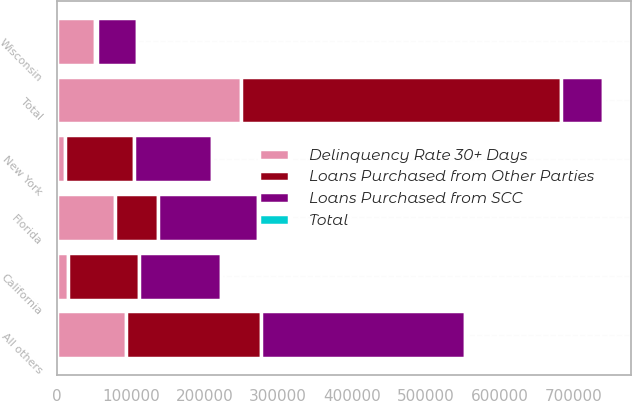Convert chart. <chart><loc_0><loc_0><loc_500><loc_500><stacked_bar_chart><ecel><fcel>Florida<fcel>California<fcel>New York<fcel>Wisconsin<fcel>All others<fcel>Total<nl><fcel>Loans Purchased from Other Parties<fcel>57396<fcel>96830<fcel>94626<fcel>2214<fcel>183578<fcel>434644<nl><fcel>Delinquency Rate 30+ Days<fcel>78999<fcel>14546<fcel>10305<fcel>51947<fcel>93243<fcel>249040<nl><fcel>Loans Purchased from SCC<fcel>136395<fcel>111376<fcel>104931<fcel>54161<fcel>276821<fcel>57396<nl><fcel>Total<fcel>20<fcel>16<fcel>15<fcel>8<fcel>41<fcel>100<nl></chart> 